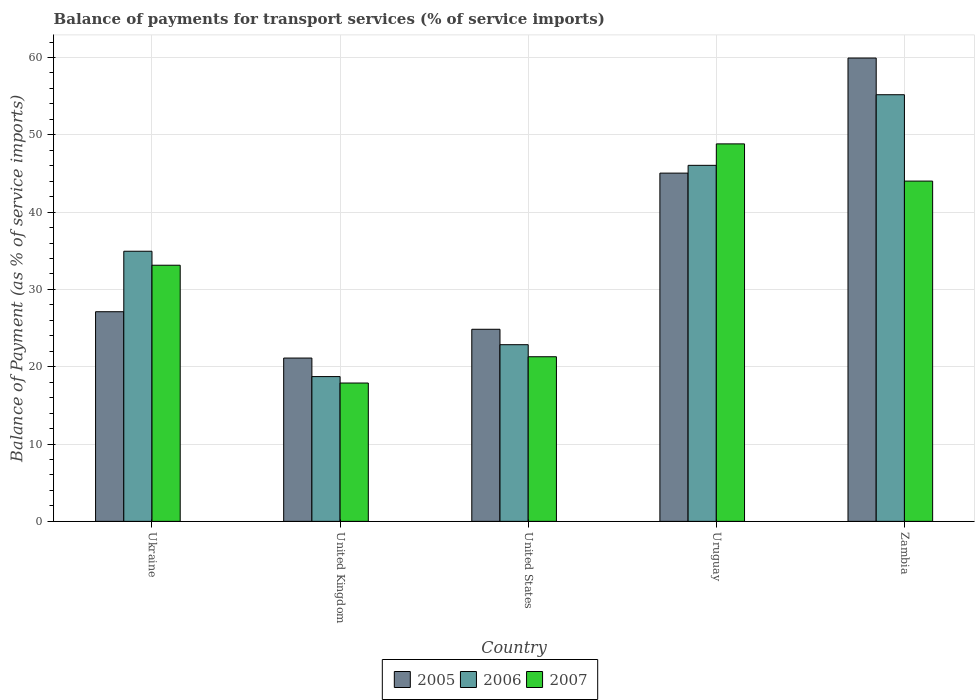How many different coloured bars are there?
Offer a very short reply. 3. Are the number of bars on each tick of the X-axis equal?
Provide a short and direct response. Yes. How many bars are there on the 5th tick from the left?
Keep it short and to the point. 3. In how many cases, is the number of bars for a given country not equal to the number of legend labels?
Your response must be concise. 0. What is the balance of payments for transport services in 2007 in Zambia?
Provide a short and direct response. 44.01. Across all countries, what is the maximum balance of payments for transport services in 2005?
Your response must be concise. 59.93. Across all countries, what is the minimum balance of payments for transport services in 2005?
Make the answer very short. 21.12. In which country was the balance of payments for transport services in 2007 maximum?
Ensure brevity in your answer.  Uruguay. In which country was the balance of payments for transport services in 2006 minimum?
Give a very brief answer. United Kingdom. What is the total balance of payments for transport services in 2006 in the graph?
Your answer should be compact. 177.75. What is the difference between the balance of payments for transport services in 2007 in United States and that in Uruguay?
Offer a terse response. -27.53. What is the difference between the balance of payments for transport services in 2005 in Uruguay and the balance of payments for transport services in 2006 in Ukraine?
Provide a short and direct response. 10.1. What is the average balance of payments for transport services in 2007 per country?
Keep it short and to the point. 33.03. What is the difference between the balance of payments for transport services of/in 2007 and balance of payments for transport services of/in 2005 in Zambia?
Keep it short and to the point. -15.91. In how many countries, is the balance of payments for transport services in 2007 greater than 6 %?
Offer a very short reply. 5. What is the ratio of the balance of payments for transport services in 2007 in United Kingdom to that in United States?
Your answer should be compact. 0.84. Is the balance of payments for transport services in 2007 in United States less than that in Uruguay?
Give a very brief answer. Yes. Is the difference between the balance of payments for transport services in 2007 in United States and Uruguay greater than the difference between the balance of payments for transport services in 2005 in United States and Uruguay?
Offer a very short reply. No. What is the difference between the highest and the second highest balance of payments for transport services in 2007?
Give a very brief answer. 15.69. What is the difference between the highest and the lowest balance of payments for transport services in 2006?
Your answer should be very brief. 36.46. In how many countries, is the balance of payments for transport services in 2006 greater than the average balance of payments for transport services in 2006 taken over all countries?
Provide a short and direct response. 2. Is it the case that in every country, the sum of the balance of payments for transport services in 2006 and balance of payments for transport services in 2005 is greater than the balance of payments for transport services in 2007?
Provide a short and direct response. Yes. Are all the bars in the graph horizontal?
Make the answer very short. No. How many countries are there in the graph?
Ensure brevity in your answer.  5. What is the difference between two consecutive major ticks on the Y-axis?
Your response must be concise. 10. Are the values on the major ticks of Y-axis written in scientific E-notation?
Your response must be concise. No. Does the graph contain any zero values?
Offer a very short reply. No. How are the legend labels stacked?
Ensure brevity in your answer.  Horizontal. What is the title of the graph?
Make the answer very short. Balance of payments for transport services (% of service imports). What is the label or title of the X-axis?
Your answer should be compact. Country. What is the label or title of the Y-axis?
Your answer should be compact. Balance of Payment (as % of service imports). What is the Balance of Payment (as % of service imports) of 2005 in Ukraine?
Make the answer very short. 27.12. What is the Balance of Payment (as % of service imports) of 2006 in Ukraine?
Provide a short and direct response. 34.94. What is the Balance of Payment (as % of service imports) of 2007 in Ukraine?
Offer a terse response. 33.13. What is the Balance of Payment (as % of service imports) of 2005 in United Kingdom?
Offer a very short reply. 21.12. What is the Balance of Payment (as % of service imports) in 2006 in United Kingdom?
Make the answer very short. 18.73. What is the Balance of Payment (as % of service imports) of 2007 in United Kingdom?
Offer a terse response. 17.89. What is the Balance of Payment (as % of service imports) of 2005 in United States?
Offer a very short reply. 24.85. What is the Balance of Payment (as % of service imports) in 2006 in United States?
Provide a succinct answer. 22.85. What is the Balance of Payment (as % of service imports) in 2007 in United States?
Make the answer very short. 21.29. What is the Balance of Payment (as % of service imports) in 2005 in Uruguay?
Offer a terse response. 45.04. What is the Balance of Payment (as % of service imports) of 2006 in Uruguay?
Provide a short and direct response. 46.05. What is the Balance of Payment (as % of service imports) of 2007 in Uruguay?
Your answer should be very brief. 48.82. What is the Balance of Payment (as % of service imports) in 2005 in Zambia?
Your answer should be compact. 59.93. What is the Balance of Payment (as % of service imports) of 2006 in Zambia?
Give a very brief answer. 55.18. What is the Balance of Payment (as % of service imports) in 2007 in Zambia?
Provide a short and direct response. 44.01. Across all countries, what is the maximum Balance of Payment (as % of service imports) of 2005?
Ensure brevity in your answer.  59.93. Across all countries, what is the maximum Balance of Payment (as % of service imports) of 2006?
Make the answer very short. 55.18. Across all countries, what is the maximum Balance of Payment (as % of service imports) of 2007?
Provide a succinct answer. 48.82. Across all countries, what is the minimum Balance of Payment (as % of service imports) in 2005?
Your response must be concise. 21.12. Across all countries, what is the minimum Balance of Payment (as % of service imports) of 2006?
Provide a short and direct response. 18.73. Across all countries, what is the minimum Balance of Payment (as % of service imports) of 2007?
Offer a terse response. 17.89. What is the total Balance of Payment (as % of service imports) of 2005 in the graph?
Make the answer very short. 178.05. What is the total Balance of Payment (as % of service imports) of 2006 in the graph?
Provide a short and direct response. 177.75. What is the total Balance of Payment (as % of service imports) in 2007 in the graph?
Your answer should be very brief. 165.15. What is the difference between the Balance of Payment (as % of service imports) of 2005 in Ukraine and that in United Kingdom?
Offer a terse response. 5.99. What is the difference between the Balance of Payment (as % of service imports) in 2006 in Ukraine and that in United Kingdom?
Offer a very short reply. 16.21. What is the difference between the Balance of Payment (as % of service imports) in 2007 in Ukraine and that in United Kingdom?
Offer a very short reply. 15.24. What is the difference between the Balance of Payment (as % of service imports) of 2005 in Ukraine and that in United States?
Make the answer very short. 2.27. What is the difference between the Balance of Payment (as % of service imports) of 2006 in Ukraine and that in United States?
Keep it short and to the point. 12.09. What is the difference between the Balance of Payment (as % of service imports) in 2007 in Ukraine and that in United States?
Provide a short and direct response. 11.84. What is the difference between the Balance of Payment (as % of service imports) in 2005 in Ukraine and that in Uruguay?
Make the answer very short. -17.93. What is the difference between the Balance of Payment (as % of service imports) in 2006 in Ukraine and that in Uruguay?
Provide a succinct answer. -11.11. What is the difference between the Balance of Payment (as % of service imports) of 2007 in Ukraine and that in Uruguay?
Offer a terse response. -15.69. What is the difference between the Balance of Payment (as % of service imports) of 2005 in Ukraine and that in Zambia?
Make the answer very short. -32.81. What is the difference between the Balance of Payment (as % of service imports) in 2006 in Ukraine and that in Zambia?
Make the answer very short. -20.24. What is the difference between the Balance of Payment (as % of service imports) in 2007 in Ukraine and that in Zambia?
Provide a succinct answer. -10.88. What is the difference between the Balance of Payment (as % of service imports) in 2005 in United Kingdom and that in United States?
Give a very brief answer. -3.72. What is the difference between the Balance of Payment (as % of service imports) in 2006 in United Kingdom and that in United States?
Offer a terse response. -4.13. What is the difference between the Balance of Payment (as % of service imports) of 2007 in United Kingdom and that in United States?
Provide a short and direct response. -3.4. What is the difference between the Balance of Payment (as % of service imports) of 2005 in United Kingdom and that in Uruguay?
Keep it short and to the point. -23.92. What is the difference between the Balance of Payment (as % of service imports) in 2006 in United Kingdom and that in Uruguay?
Offer a terse response. -27.32. What is the difference between the Balance of Payment (as % of service imports) of 2007 in United Kingdom and that in Uruguay?
Your answer should be very brief. -30.93. What is the difference between the Balance of Payment (as % of service imports) of 2005 in United Kingdom and that in Zambia?
Give a very brief answer. -38.8. What is the difference between the Balance of Payment (as % of service imports) of 2006 in United Kingdom and that in Zambia?
Your response must be concise. -36.46. What is the difference between the Balance of Payment (as % of service imports) in 2007 in United Kingdom and that in Zambia?
Your response must be concise. -26.12. What is the difference between the Balance of Payment (as % of service imports) in 2005 in United States and that in Uruguay?
Your response must be concise. -20.2. What is the difference between the Balance of Payment (as % of service imports) of 2006 in United States and that in Uruguay?
Offer a very short reply. -23.2. What is the difference between the Balance of Payment (as % of service imports) of 2007 in United States and that in Uruguay?
Make the answer very short. -27.53. What is the difference between the Balance of Payment (as % of service imports) in 2005 in United States and that in Zambia?
Give a very brief answer. -35.08. What is the difference between the Balance of Payment (as % of service imports) of 2006 in United States and that in Zambia?
Ensure brevity in your answer.  -32.33. What is the difference between the Balance of Payment (as % of service imports) in 2007 in United States and that in Zambia?
Provide a succinct answer. -22.72. What is the difference between the Balance of Payment (as % of service imports) of 2005 in Uruguay and that in Zambia?
Your response must be concise. -14.88. What is the difference between the Balance of Payment (as % of service imports) in 2006 in Uruguay and that in Zambia?
Make the answer very short. -9.13. What is the difference between the Balance of Payment (as % of service imports) of 2007 in Uruguay and that in Zambia?
Offer a terse response. 4.81. What is the difference between the Balance of Payment (as % of service imports) of 2005 in Ukraine and the Balance of Payment (as % of service imports) of 2006 in United Kingdom?
Offer a very short reply. 8.39. What is the difference between the Balance of Payment (as % of service imports) in 2005 in Ukraine and the Balance of Payment (as % of service imports) in 2007 in United Kingdom?
Your answer should be very brief. 9.22. What is the difference between the Balance of Payment (as % of service imports) in 2006 in Ukraine and the Balance of Payment (as % of service imports) in 2007 in United Kingdom?
Provide a short and direct response. 17.04. What is the difference between the Balance of Payment (as % of service imports) of 2005 in Ukraine and the Balance of Payment (as % of service imports) of 2006 in United States?
Give a very brief answer. 4.26. What is the difference between the Balance of Payment (as % of service imports) in 2005 in Ukraine and the Balance of Payment (as % of service imports) in 2007 in United States?
Make the answer very short. 5.82. What is the difference between the Balance of Payment (as % of service imports) of 2006 in Ukraine and the Balance of Payment (as % of service imports) of 2007 in United States?
Ensure brevity in your answer.  13.65. What is the difference between the Balance of Payment (as % of service imports) in 2005 in Ukraine and the Balance of Payment (as % of service imports) in 2006 in Uruguay?
Offer a terse response. -18.93. What is the difference between the Balance of Payment (as % of service imports) of 2005 in Ukraine and the Balance of Payment (as % of service imports) of 2007 in Uruguay?
Offer a very short reply. -21.71. What is the difference between the Balance of Payment (as % of service imports) of 2006 in Ukraine and the Balance of Payment (as % of service imports) of 2007 in Uruguay?
Offer a terse response. -13.89. What is the difference between the Balance of Payment (as % of service imports) of 2005 in Ukraine and the Balance of Payment (as % of service imports) of 2006 in Zambia?
Offer a very short reply. -28.07. What is the difference between the Balance of Payment (as % of service imports) of 2005 in Ukraine and the Balance of Payment (as % of service imports) of 2007 in Zambia?
Give a very brief answer. -16.9. What is the difference between the Balance of Payment (as % of service imports) of 2006 in Ukraine and the Balance of Payment (as % of service imports) of 2007 in Zambia?
Your response must be concise. -9.08. What is the difference between the Balance of Payment (as % of service imports) of 2005 in United Kingdom and the Balance of Payment (as % of service imports) of 2006 in United States?
Your answer should be compact. -1.73. What is the difference between the Balance of Payment (as % of service imports) of 2005 in United Kingdom and the Balance of Payment (as % of service imports) of 2007 in United States?
Your response must be concise. -0.17. What is the difference between the Balance of Payment (as % of service imports) of 2006 in United Kingdom and the Balance of Payment (as % of service imports) of 2007 in United States?
Your answer should be compact. -2.57. What is the difference between the Balance of Payment (as % of service imports) in 2005 in United Kingdom and the Balance of Payment (as % of service imports) in 2006 in Uruguay?
Offer a terse response. -24.93. What is the difference between the Balance of Payment (as % of service imports) of 2005 in United Kingdom and the Balance of Payment (as % of service imports) of 2007 in Uruguay?
Give a very brief answer. -27.7. What is the difference between the Balance of Payment (as % of service imports) in 2006 in United Kingdom and the Balance of Payment (as % of service imports) in 2007 in Uruguay?
Offer a very short reply. -30.1. What is the difference between the Balance of Payment (as % of service imports) in 2005 in United Kingdom and the Balance of Payment (as % of service imports) in 2006 in Zambia?
Give a very brief answer. -34.06. What is the difference between the Balance of Payment (as % of service imports) in 2005 in United Kingdom and the Balance of Payment (as % of service imports) in 2007 in Zambia?
Keep it short and to the point. -22.89. What is the difference between the Balance of Payment (as % of service imports) in 2006 in United Kingdom and the Balance of Payment (as % of service imports) in 2007 in Zambia?
Keep it short and to the point. -25.29. What is the difference between the Balance of Payment (as % of service imports) in 2005 in United States and the Balance of Payment (as % of service imports) in 2006 in Uruguay?
Your answer should be compact. -21.2. What is the difference between the Balance of Payment (as % of service imports) in 2005 in United States and the Balance of Payment (as % of service imports) in 2007 in Uruguay?
Provide a short and direct response. -23.98. What is the difference between the Balance of Payment (as % of service imports) of 2006 in United States and the Balance of Payment (as % of service imports) of 2007 in Uruguay?
Ensure brevity in your answer.  -25.97. What is the difference between the Balance of Payment (as % of service imports) of 2005 in United States and the Balance of Payment (as % of service imports) of 2006 in Zambia?
Ensure brevity in your answer.  -30.34. What is the difference between the Balance of Payment (as % of service imports) in 2005 in United States and the Balance of Payment (as % of service imports) in 2007 in Zambia?
Your answer should be very brief. -19.17. What is the difference between the Balance of Payment (as % of service imports) in 2006 in United States and the Balance of Payment (as % of service imports) in 2007 in Zambia?
Offer a very short reply. -21.16. What is the difference between the Balance of Payment (as % of service imports) of 2005 in Uruguay and the Balance of Payment (as % of service imports) of 2006 in Zambia?
Provide a short and direct response. -10.14. What is the difference between the Balance of Payment (as % of service imports) in 2005 in Uruguay and the Balance of Payment (as % of service imports) in 2007 in Zambia?
Ensure brevity in your answer.  1.03. What is the difference between the Balance of Payment (as % of service imports) in 2006 in Uruguay and the Balance of Payment (as % of service imports) in 2007 in Zambia?
Provide a succinct answer. 2.04. What is the average Balance of Payment (as % of service imports) in 2005 per country?
Offer a very short reply. 35.61. What is the average Balance of Payment (as % of service imports) in 2006 per country?
Your response must be concise. 35.55. What is the average Balance of Payment (as % of service imports) of 2007 per country?
Provide a short and direct response. 33.03. What is the difference between the Balance of Payment (as % of service imports) of 2005 and Balance of Payment (as % of service imports) of 2006 in Ukraine?
Offer a terse response. -7.82. What is the difference between the Balance of Payment (as % of service imports) of 2005 and Balance of Payment (as % of service imports) of 2007 in Ukraine?
Give a very brief answer. -6.01. What is the difference between the Balance of Payment (as % of service imports) in 2006 and Balance of Payment (as % of service imports) in 2007 in Ukraine?
Your answer should be compact. 1.81. What is the difference between the Balance of Payment (as % of service imports) in 2005 and Balance of Payment (as % of service imports) in 2006 in United Kingdom?
Offer a terse response. 2.4. What is the difference between the Balance of Payment (as % of service imports) in 2005 and Balance of Payment (as % of service imports) in 2007 in United Kingdom?
Keep it short and to the point. 3.23. What is the difference between the Balance of Payment (as % of service imports) in 2006 and Balance of Payment (as % of service imports) in 2007 in United Kingdom?
Your answer should be compact. 0.83. What is the difference between the Balance of Payment (as % of service imports) of 2005 and Balance of Payment (as % of service imports) of 2006 in United States?
Keep it short and to the point. 2. What is the difference between the Balance of Payment (as % of service imports) of 2005 and Balance of Payment (as % of service imports) of 2007 in United States?
Make the answer very short. 3.55. What is the difference between the Balance of Payment (as % of service imports) of 2006 and Balance of Payment (as % of service imports) of 2007 in United States?
Offer a very short reply. 1.56. What is the difference between the Balance of Payment (as % of service imports) of 2005 and Balance of Payment (as % of service imports) of 2006 in Uruguay?
Make the answer very short. -1.01. What is the difference between the Balance of Payment (as % of service imports) in 2005 and Balance of Payment (as % of service imports) in 2007 in Uruguay?
Your response must be concise. -3.78. What is the difference between the Balance of Payment (as % of service imports) of 2006 and Balance of Payment (as % of service imports) of 2007 in Uruguay?
Offer a very short reply. -2.77. What is the difference between the Balance of Payment (as % of service imports) of 2005 and Balance of Payment (as % of service imports) of 2006 in Zambia?
Provide a succinct answer. 4.74. What is the difference between the Balance of Payment (as % of service imports) in 2005 and Balance of Payment (as % of service imports) in 2007 in Zambia?
Provide a succinct answer. 15.91. What is the difference between the Balance of Payment (as % of service imports) in 2006 and Balance of Payment (as % of service imports) in 2007 in Zambia?
Ensure brevity in your answer.  11.17. What is the ratio of the Balance of Payment (as % of service imports) in 2005 in Ukraine to that in United Kingdom?
Offer a very short reply. 1.28. What is the ratio of the Balance of Payment (as % of service imports) in 2006 in Ukraine to that in United Kingdom?
Offer a very short reply. 1.87. What is the ratio of the Balance of Payment (as % of service imports) in 2007 in Ukraine to that in United Kingdom?
Your answer should be compact. 1.85. What is the ratio of the Balance of Payment (as % of service imports) of 2005 in Ukraine to that in United States?
Your answer should be compact. 1.09. What is the ratio of the Balance of Payment (as % of service imports) of 2006 in Ukraine to that in United States?
Offer a terse response. 1.53. What is the ratio of the Balance of Payment (as % of service imports) in 2007 in Ukraine to that in United States?
Make the answer very short. 1.56. What is the ratio of the Balance of Payment (as % of service imports) in 2005 in Ukraine to that in Uruguay?
Offer a terse response. 0.6. What is the ratio of the Balance of Payment (as % of service imports) in 2006 in Ukraine to that in Uruguay?
Offer a very short reply. 0.76. What is the ratio of the Balance of Payment (as % of service imports) in 2007 in Ukraine to that in Uruguay?
Ensure brevity in your answer.  0.68. What is the ratio of the Balance of Payment (as % of service imports) in 2005 in Ukraine to that in Zambia?
Your response must be concise. 0.45. What is the ratio of the Balance of Payment (as % of service imports) of 2006 in Ukraine to that in Zambia?
Keep it short and to the point. 0.63. What is the ratio of the Balance of Payment (as % of service imports) of 2007 in Ukraine to that in Zambia?
Offer a very short reply. 0.75. What is the ratio of the Balance of Payment (as % of service imports) of 2005 in United Kingdom to that in United States?
Your response must be concise. 0.85. What is the ratio of the Balance of Payment (as % of service imports) of 2006 in United Kingdom to that in United States?
Provide a succinct answer. 0.82. What is the ratio of the Balance of Payment (as % of service imports) of 2007 in United Kingdom to that in United States?
Give a very brief answer. 0.84. What is the ratio of the Balance of Payment (as % of service imports) in 2005 in United Kingdom to that in Uruguay?
Make the answer very short. 0.47. What is the ratio of the Balance of Payment (as % of service imports) in 2006 in United Kingdom to that in Uruguay?
Your answer should be very brief. 0.41. What is the ratio of the Balance of Payment (as % of service imports) of 2007 in United Kingdom to that in Uruguay?
Provide a short and direct response. 0.37. What is the ratio of the Balance of Payment (as % of service imports) in 2005 in United Kingdom to that in Zambia?
Offer a terse response. 0.35. What is the ratio of the Balance of Payment (as % of service imports) of 2006 in United Kingdom to that in Zambia?
Offer a very short reply. 0.34. What is the ratio of the Balance of Payment (as % of service imports) of 2007 in United Kingdom to that in Zambia?
Your answer should be very brief. 0.41. What is the ratio of the Balance of Payment (as % of service imports) in 2005 in United States to that in Uruguay?
Offer a terse response. 0.55. What is the ratio of the Balance of Payment (as % of service imports) in 2006 in United States to that in Uruguay?
Provide a succinct answer. 0.5. What is the ratio of the Balance of Payment (as % of service imports) of 2007 in United States to that in Uruguay?
Offer a very short reply. 0.44. What is the ratio of the Balance of Payment (as % of service imports) of 2005 in United States to that in Zambia?
Keep it short and to the point. 0.41. What is the ratio of the Balance of Payment (as % of service imports) of 2006 in United States to that in Zambia?
Your response must be concise. 0.41. What is the ratio of the Balance of Payment (as % of service imports) in 2007 in United States to that in Zambia?
Ensure brevity in your answer.  0.48. What is the ratio of the Balance of Payment (as % of service imports) of 2005 in Uruguay to that in Zambia?
Make the answer very short. 0.75. What is the ratio of the Balance of Payment (as % of service imports) of 2006 in Uruguay to that in Zambia?
Make the answer very short. 0.83. What is the ratio of the Balance of Payment (as % of service imports) of 2007 in Uruguay to that in Zambia?
Provide a succinct answer. 1.11. What is the difference between the highest and the second highest Balance of Payment (as % of service imports) in 2005?
Your answer should be compact. 14.88. What is the difference between the highest and the second highest Balance of Payment (as % of service imports) in 2006?
Your answer should be very brief. 9.13. What is the difference between the highest and the second highest Balance of Payment (as % of service imports) in 2007?
Offer a very short reply. 4.81. What is the difference between the highest and the lowest Balance of Payment (as % of service imports) of 2005?
Give a very brief answer. 38.8. What is the difference between the highest and the lowest Balance of Payment (as % of service imports) of 2006?
Give a very brief answer. 36.46. What is the difference between the highest and the lowest Balance of Payment (as % of service imports) in 2007?
Your answer should be compact. 30.93. 